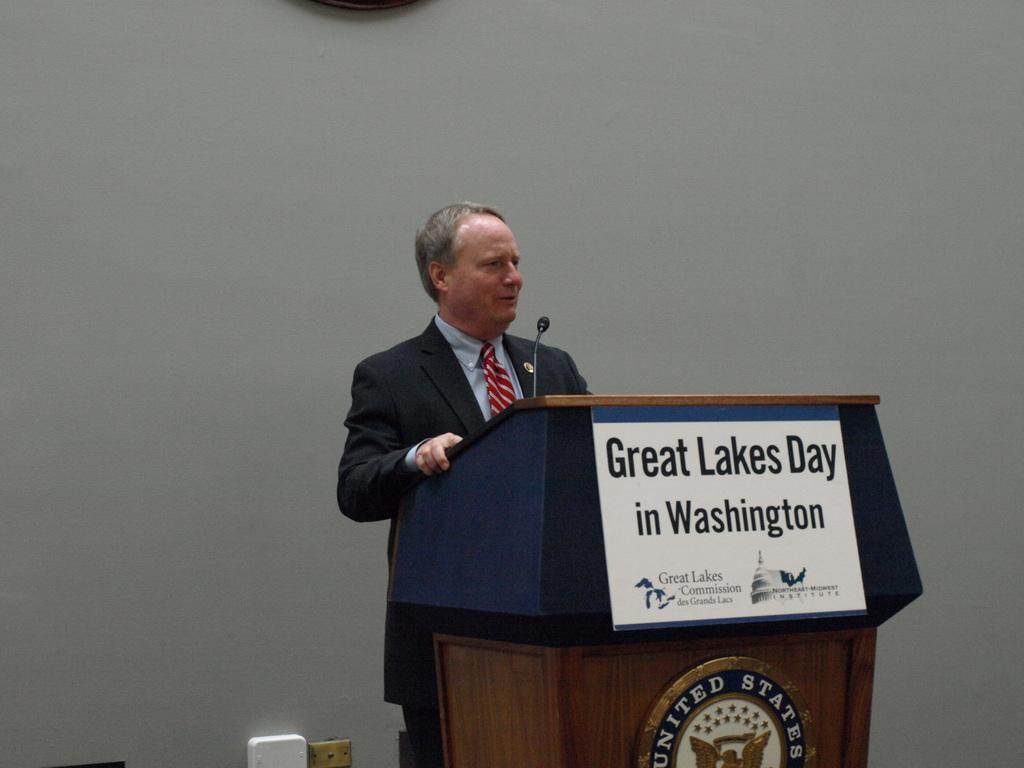Provide a one-sentence caption for the provided image. a Great Lakes Day sign that is on the podium. 